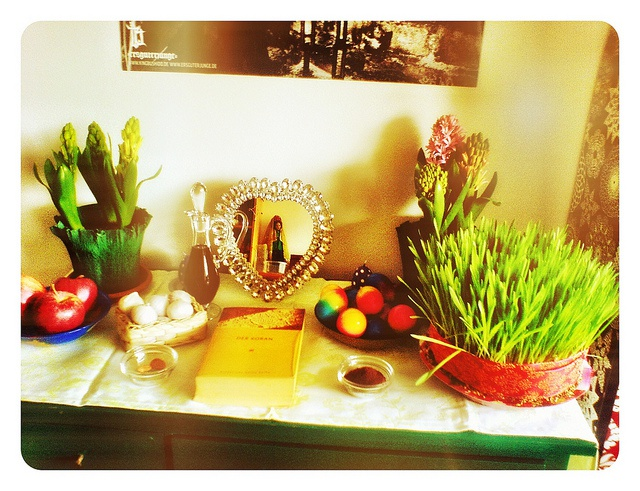Describe the objects in this image and their specific colors. I can see potted plant in white, yellow, lime, maroon, and olive tones, potted plant in white, maroon, olive, and black tones, potted plant in white, maroon, brown, olive, and khaki tones, book in white, gold, orange, and khaki tones, and bowl in white, maroon, black, and brown tones in this image. 